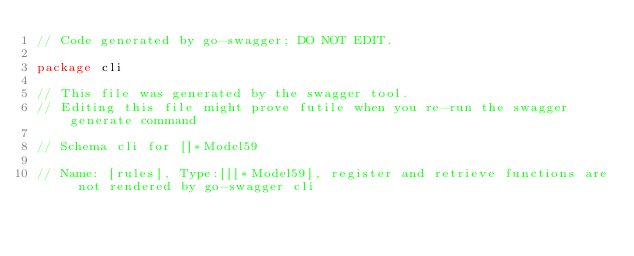Convert code to text. <code><loc_0><loc_0><loc_500><loc_500><_Go_>// Code generated by go-swagger; DO NOT EDIT.

package cli

// This file was generated by the swagger tool.
// Editing this file might prove futile when you re-run the swagger generate command

// Schema cli for []*Model59

// Name: [rules], Type:[[]*Model59], register and retrieve functions are not rendered by go-swagger cli
</code> 